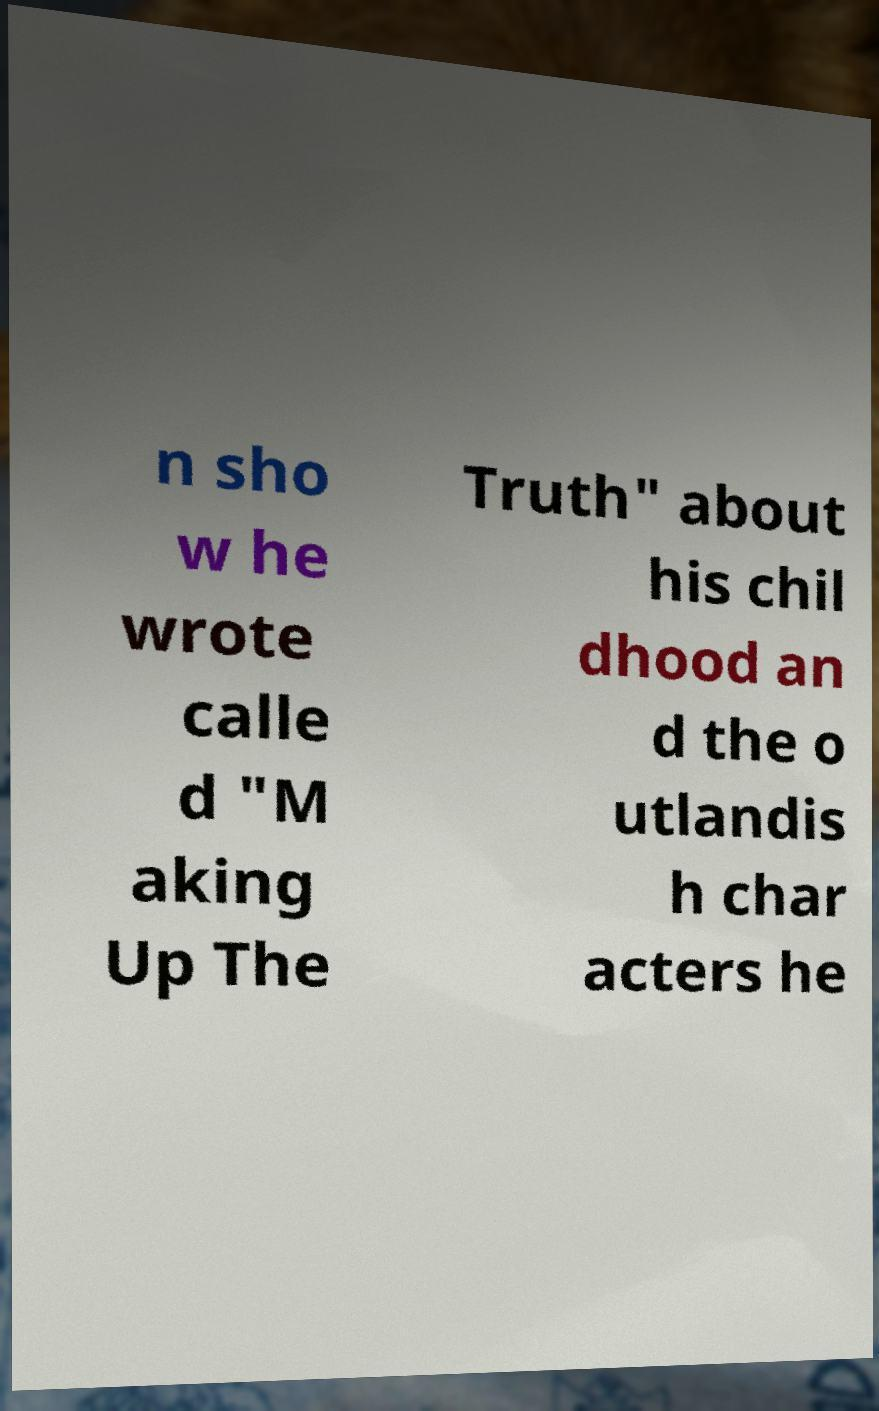Could you assist in decoding the text presented in this image and type it out clearly? n sho w he wrote calle d "M aking Up The Truth" about his chil dhood an d the o utlandis h char acters he 